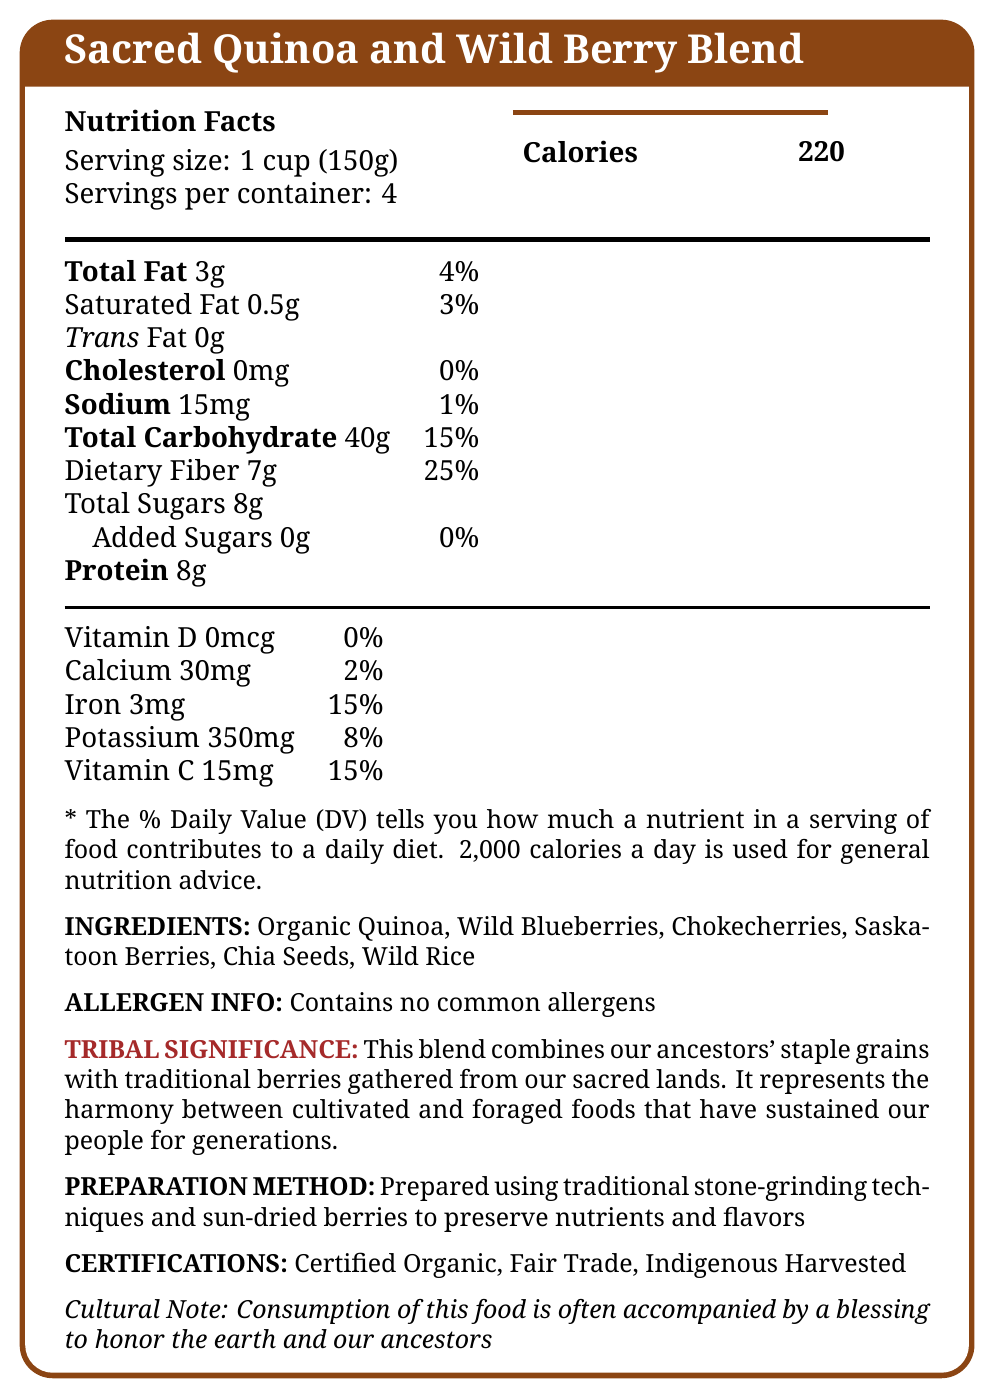who is the tribal elder representing this document? There is no specific information about a tribal elder mentioned in the document.
Answer: Cannot be determined what is the serving size for the Sacred Quinoa and Wild Berry Blend? The document specifies that the serving size is 1 cup (150g).
Answer: 1 cup (150g) how many servings are there per container? The document states that there are 4 servings per container.
Answer: 4 servings what is the total fat content per serving? According to the nutrition facts, the total fat content per serving is 3g.
Answer: 3g does the Sacred Quinoa and Wild Berry Blend contain any common allergens? The document specifies that it contains no common allergens.
Answer: No how much dietary fiber does one serving provide? The document shows that one serving provides 7g of dietary fiber.
Answer: 7g what percentage of the daily value does the iron content in one serving represent? The iron content in one serving represents 15% of the daily value.
Answer: 15% what ingredients are included in the Sacred Quinoa and Wild Berry Blend? The document lists these ingredients under the "Ingredients" section.
Answer: Organic Quinoa, Wild Blueberries, Chokecherries, Saskatoon Berries, Chia Seeds, Wild Rice describe the significance of the blend according to the document. According to the document, the blend holds tribal significance by combining historical and sacred elements of food.
Answer: The blend combines ancestral staple grains with traditional berries gathered from sacred lands, representing the harmony between cultivated and foraged foods that sustained people for generations. what certifications does the Sacred Quinoa and Wild Berry Blend have? A. USDA Organic, Non-GMO B. Certified Organic, Fair Trade, Indigenous Harvested C. Fair Trade, Certified Vegan D. Gluten-Free, Kosher The document lists these certifications: Certified Organic, Fair Trade, Indigenous Harvested.
Answer: B. Certified Organic, Fair Trade, Indigenous Harvested what percentage of the daily value for calcium does one serving provide? A. 0% B. 2% C. 8% D. 15% The document shows that the calcium content in one serving represents 2% of the daily value.
Answer: B. 2% if a person consumes 2 servings, how many grams of total carbohydrates will they intake? Each serving has 40g of total carbohydrates. Consuming 2 servings would result in 2 * 40g = 80g.
Answer: 80g is there any vitamin D in the Sacred Quinoa and Wild Berry Blend? The document indicates that the blend contains 0mcg of vitamin D, which is 0% of the daily value.
Answer: No how is the Sacred Quinoa and Wild Berry Blend prepared? The document describes the preparation method in detail.
Answer: It is prepared using traditional stone-grinding techniques and sun-dried berries to preserve nutrients and flavors. summarize the main idea of the document. The main idea of the document revolves around the health benefits, cultural importance, and detailed nutritional information of the Sacred Quinoa and Wild Berry Blend, including its preparation and certifications.
Answer: The document provides nutrition facts, ingredient details, and cultural significance for Sacred Quinoa and Wild Berry Blend, a product that combines traditional grains and berries with certifications for organic and fair trade practices. It highlights the blend’s health benefits, preparation methods, and its role in honoring ancestral traditions. what traditional techniques are utilized in the preparation of this blend? The document specifies that traditional stone-grinding techniques and sun-dried berries are used in the preparation.
Answer: Stone-grinding techniques and sun-dried berries. Is there any added sugar in the Sacred Quinoa and Wild Berry Blend? The total added sugars are listed as 0g in the document.
Answer: No what is the cultural practice associated with the consumption of this blend? The document notes that a blessing for the earth and ancestors often accompanies the consumption of this food.
Answer: The consumption of this food is often accompanied by a blessing to honor the earth and ancestors. what is the amount of potassium in one serving of the Sacred Quinoa and Wild Berry Blend? The document indicates that one serving contains 350mg of potassium.
Answer: 350mg 